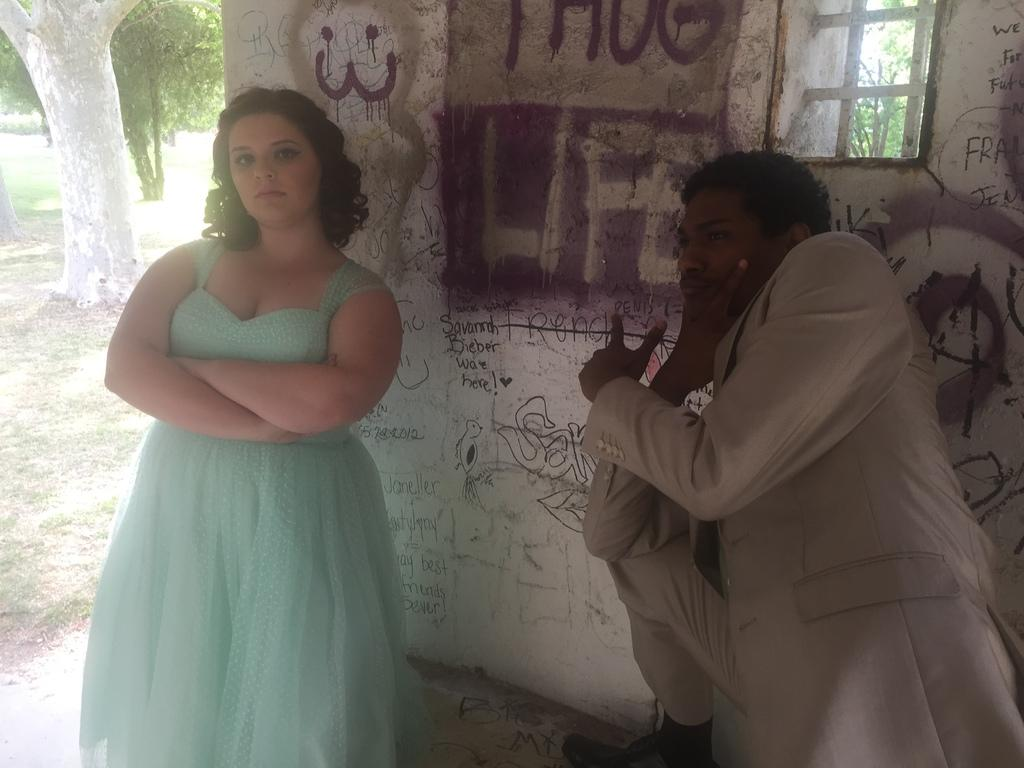How many people are in the image? There are two people in the image. What can be seen on the wall behind the people? There is text and a painting on the wall behind the people. What is visible in the background of the image? There is a window, trees, and grass visible in the background of the image. How much money is being exchanged between the people in the image? There is no indication of money or any exchange taking place in the image. What type of land can be seen in the background of the image? There is no land visible in the image; only trees and grass are present in the background. 